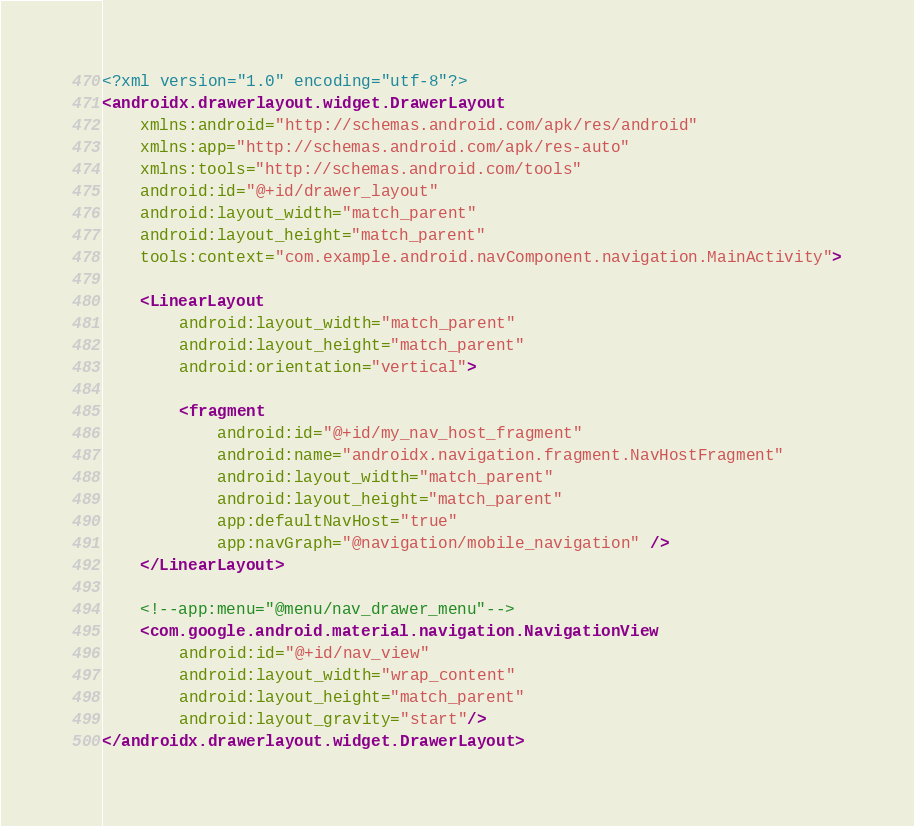Convert code to text. <code><loc_0><loc_0><loc_500><loc_500><_XML_><?xml version="1.0" encoding="utf-8"?>
<androidx.drawerlayout.widget.DrawerLayout
    xmlns:android="http://schemas.android.com/apk/res/android"
    xmlns:app="http://schemas.android.com/apk/res-auto"
    xmlns:tools="http://schemas.android.com/tools"
    android:id="@+id/drawer_layout"
    android:layout_width="match_parent"
    android:layout_height="match_parent"
    tools:context="com.example.android.navComponent.navigation.MainActivity">

    <LinearLayout
        android:layout_width="match_parent"
        android:layout_height="match_parent"
        android:orientation="vertical">

        <fragment
            android:id="@+id/my_nav_host_fragment"
            android:name="androidx.navigation.fragment.NavHostFragment"
            android:layout_width="match_parent"
            android:layout_height="match_parent"
            app:defaultNavHost="true"
            app:navGraph="@navigation/mobile_navigation" />
    </LinearLayout>

    <!--app:menu="@menu/nav_drawer_menu"-->
    <com.google.android.material.navigation.NavigationView
        android:id="@+id/nav_view"
        android:layout_width="wrap_content"
        android:layout_height="match_parent"
        android:layout_gravity="start"/>
</androidx.drawerlayout.widget.DrawerLayout>
</code> 